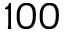Convert formula to latex. <formula><loc_0><loc_0><loc_500><loc_500>1 0 0</formula> 